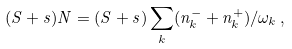Convert formula to latex. <formula><loc_0><loc_0><loc_500><loc_500>( S + s ) N = ( S + s ) \sum _ { k } ( n _ { k } ^ { - } + n _ { k } ^ { + } ) / \omega _ { k } \, ,</formula> 